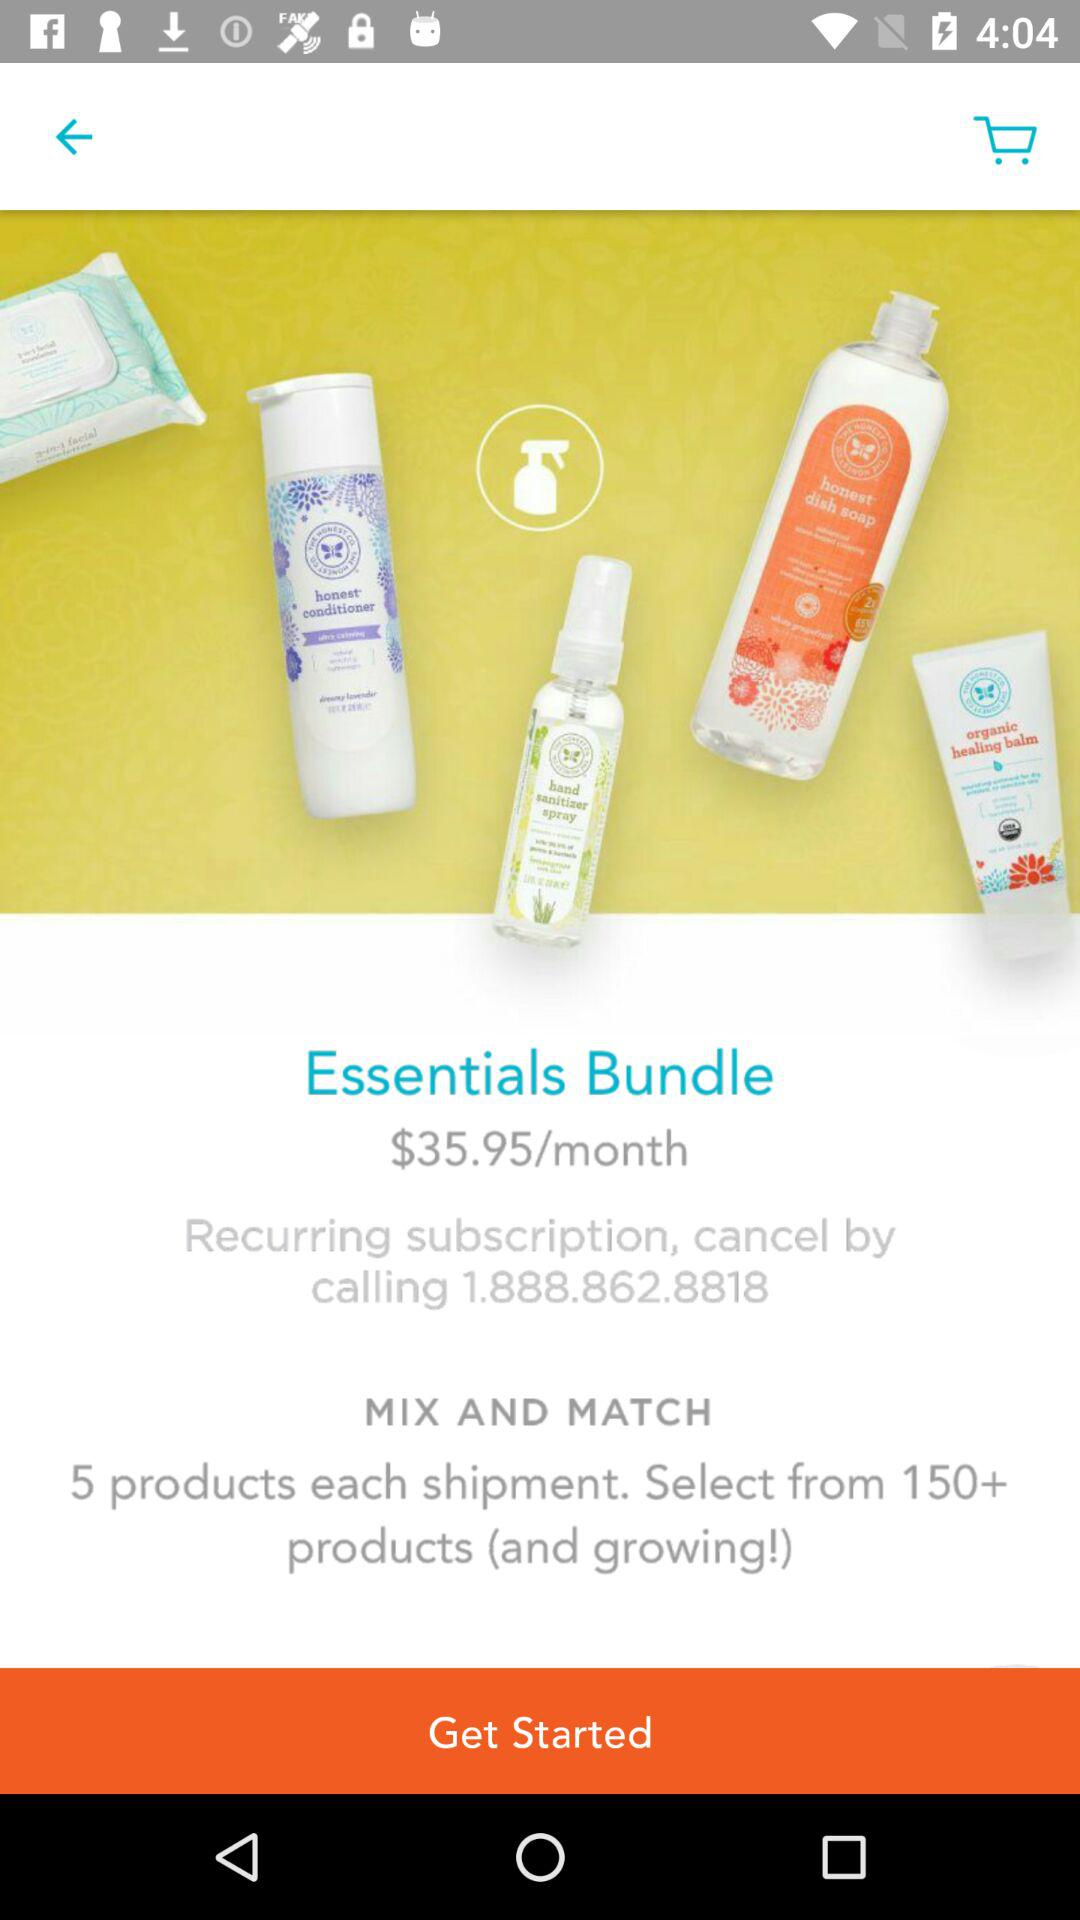How many products are there in each shipment? There are 5 products in each shipment. 